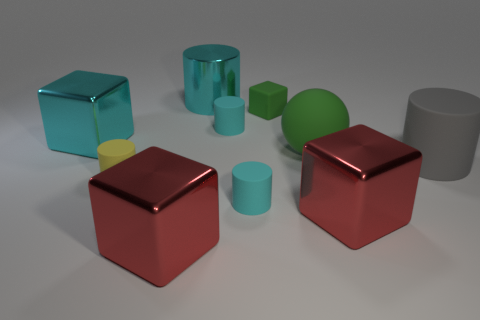What is the material of the cyan object in front of the large gray matte object?
Your answer should be very brief. Rubber. Do the large cyan object behind the green block and the red object to the right of the tiny block have the same shape?
Offer a terse response. No. Are there an equal number of metallic cylinders in front of the cyan cube and blue objects?
Ensure brevity in your answer.  Yes. How many small cyan cylinders have the same material as the small yellow object?
Provide a short and direct response. 2. What color is the big ball that is the same material as the green cube?
Offer a very short reply. Green. Do the green ball and the matte cylinder behind the big gray cylinder have the same size?
Offer a very short reply. No. There is a tiny yellow thing; what shape is it?
Ensure brevity in your answer.  Cylinder. How many shiny cubes have the same color as the big ball?
Provide a succinct answer. 0. The large rubber thing that is the same shape as the small yellow object is what color?
Provide a short and direct response. Gray. There is a large red metal thing on the right side of the big rubber ball; what number of metal things are behind it?
Your answer should be compact. 2. 